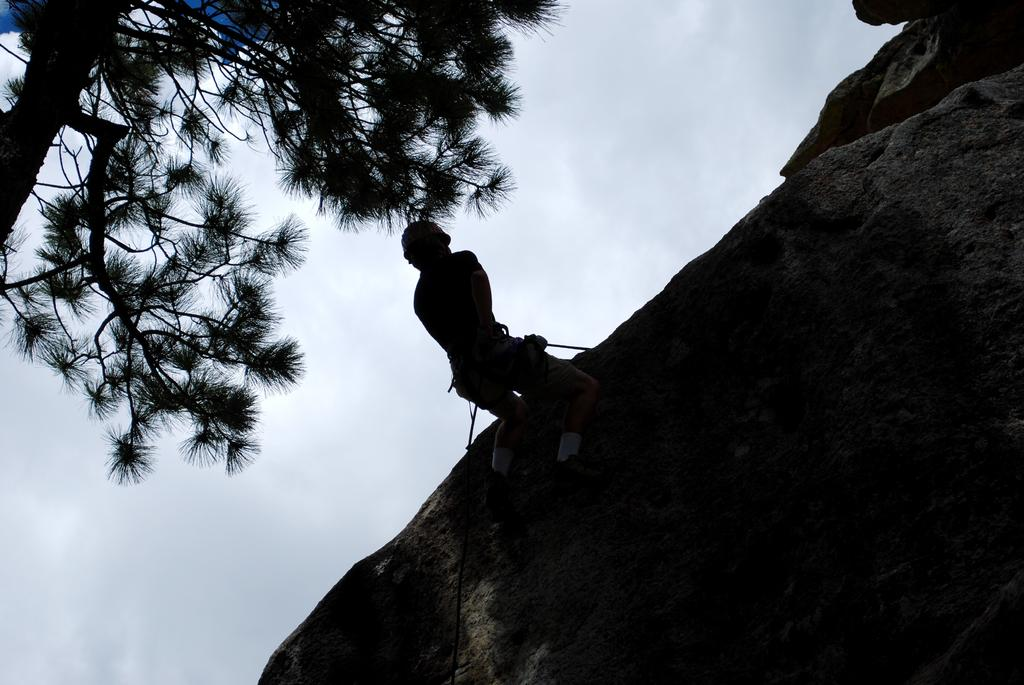What is the main subject of the image? There is a person in the image. What is the person doing in the image? The person is climbing a mountain. Are there any other objects or elements in the image besides the person? Yes, there is a tree in the image. What can be seen in the background of the image? The sky is visible in the background of the image. How would you describe the weather based on the appearance of the sky? The sky appears to be cloudy. What type of trade is being conducted at the top of the mountain in the image? There is no indication of any trade being conducted in the image; the person is simply climbing the mountain. How many cherries can be seen on the tree in the image? There is no tree with cherries present in the image; the tree is not described in detail. 